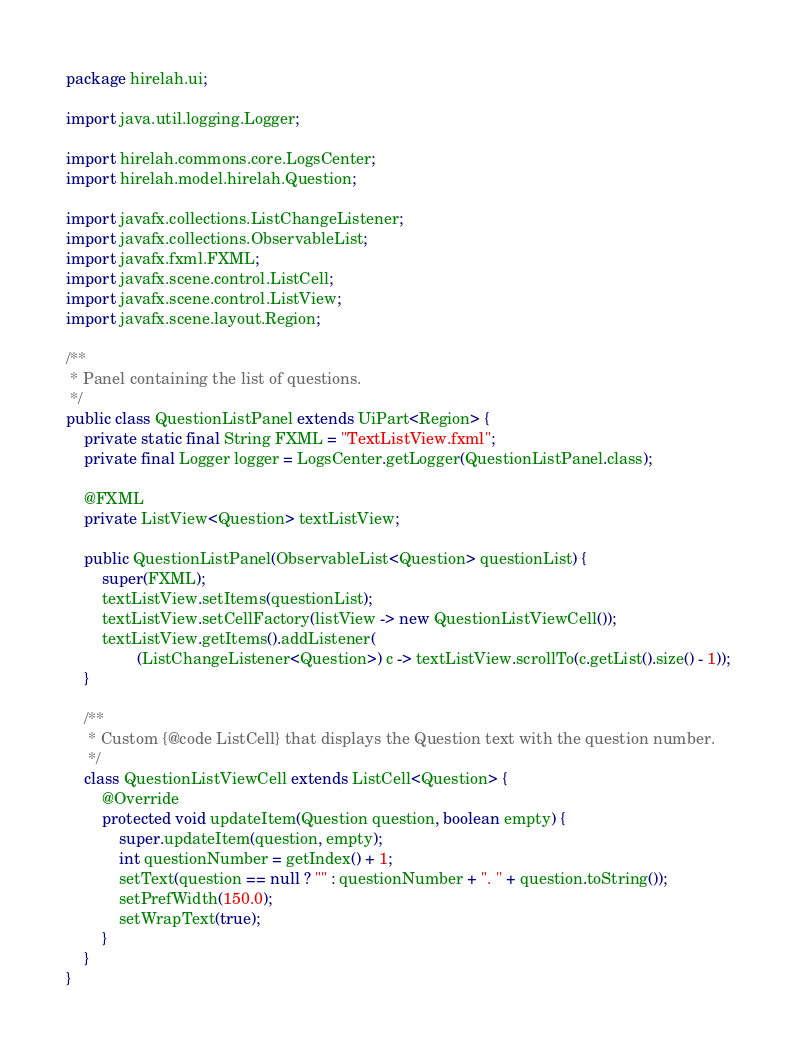Convert code to text. <code><loc_0><loc_0><loc_500><loc_500><_Java_>package hirelah.ui;

import java.util.logging.Logger;

import hirelah.commons.core.LogsCenter;
import hirelah.model.hirelah.Question;

import javafx.collections.ListChangeListener;
import javafx.collections.ObservableList;
import javafx.fxml.FXML;
import javafx.scene.control.ListCell;
import javafx.scene.control.ListView;
import javafx.scene.layout.Region;

/**
 * Panel containing the list of questions.
 */
public class QuestionListPanel extends UiPart<Region> {
    private static final String FXML = "TextListView.fxml";
    private final Logger logger = LogsCenter.getLogger(QuestionListPanel.class);

    @FXML
    private ListView<Question> textListView;

    public QuestionListPanel(ObservableList<Question> questionList) {
        super(FXML);
        textListView.setItems(questionList);
        textListView.setCellFactory(listView -> new QuestionListViewCell());
        textListView.getItems().addListener(
                (ListChangeListener<Question>) c -> textListView.scrollTo(c.getList().size() - 1));
    }

    /**
     * Custom {@code ListCell} that displays the Question text with the question number.
     */
    class QuestionListViewCell extends ListCell<Question> {
        @Override
        protected void updateItem(Question question, boolean empty) {
            super.updateItem(question, empty);
            int questionNumber = getIndex() + 1;
            setText(question == null ? "" : questionNumber + ". " + question.toString());
            setPrefWidth(150.0);
            setWrapText(true);
        }
    }
}
</code> 